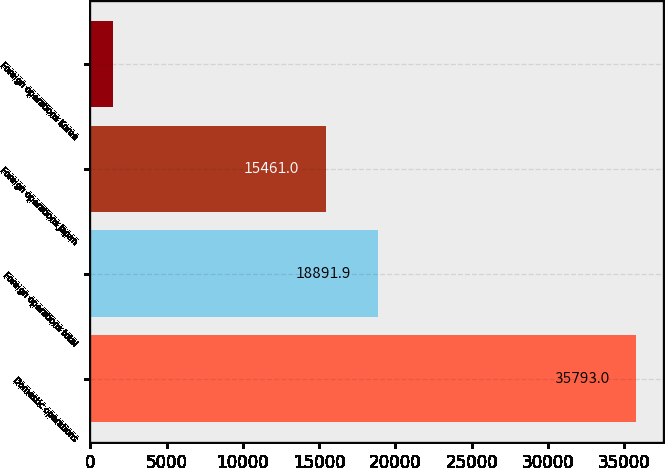Convert chart to OTSL. <chart><loc_0><loc_0><loc_500><loc_500><bar_chart><fcel>Domestic operations<fcel>Foreign operations total<fcel>Foreign operations Japan<fcel>Foreign operations Korea<nl><fcel>35793<fcel>18891.9<fcel>15461<fcel>1484<nl></chart> 